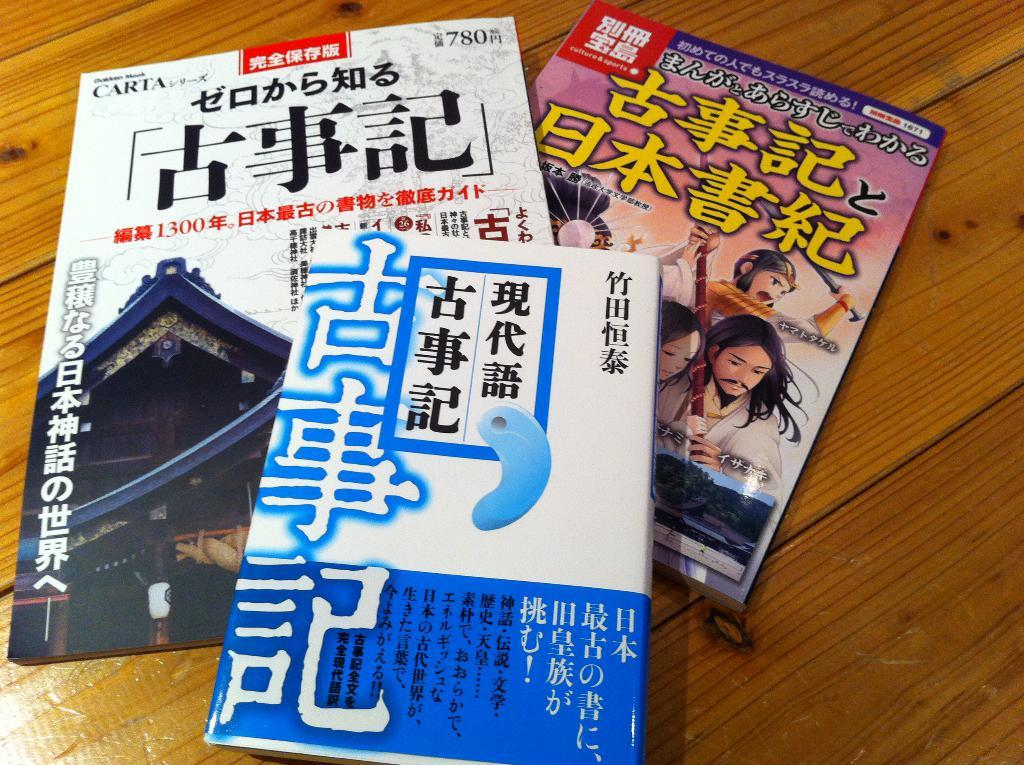Provide a one-sentence caption for the provided image. A stack of books with Japanese characters written on them. 